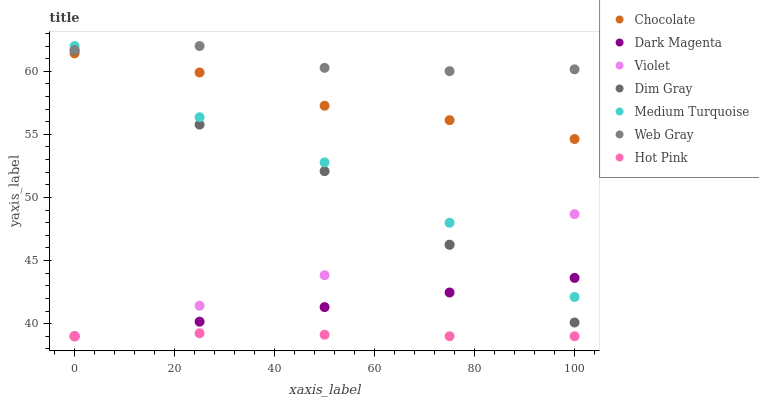Does Hot Pink have the minimum area under the curve?
Answer yes or no. Yes. Does Web Gray have the maximum area under the curve?
Answer yes or no. Yes. Does Dark Magenta have the minimum area under the curve?
Answer yes or no. No. Does Dark Magenta have the maximum area under the curve?
Answer yes or no. No. Is Dark Magenta the smoothest?
Answer yes or no. Yes. Is Dim Gray the roughest?
Answer yes or no. Yes. Is Hot Pink the smoothest?
Answer yes or no. No. Is Hot Pink the roughest?
Answer yes or no. No. Does Dark Magenta have the lowest value?
Answer yes or no. Yes. Does Chocolate have the lowest value?
Answer yes or no. No. Does Medium Turquoise have the highest value?
Answer yes or no. Yes. Does Dark Magenta have the highest value?
Answer yes or no. No. Is Hot Pink less than Web Gray?
Answer yes or no. Yes. Is Web Gray greater than Dim Gray?
Answer yes or no. Yes. Does Chocolate intersect Medium Turquoise?
Answer yes or no. Yes. Is Chocolate less than Medium Turquoise?
Answer yes or no. No. Is Chocolate greater than Medium Turquoise?
Answer yes or no. No. Does Hot Pink intersect Web Gray?
Answer yes or no. No. 